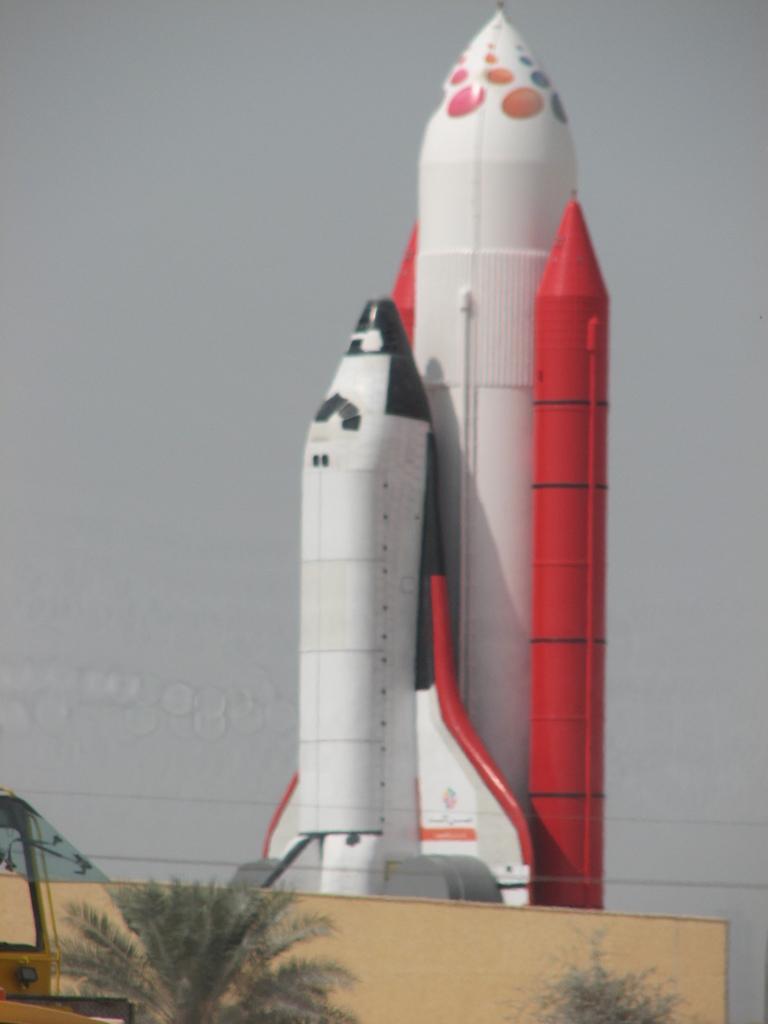Can you describe this image briefly? In this image in the center there is an airplane, and at the bottom there is a wall trees and one vehicle and in the background there is sky. 